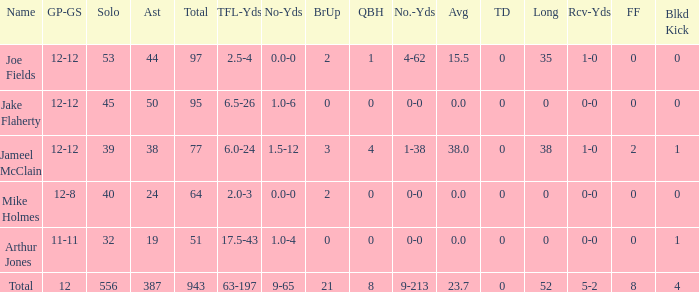How many yards for the player with tfl-yds of 2.5-4? 4-62. 